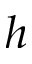<formula> <loc_0><loc_0><loc_500><loc_500>h</formula> 